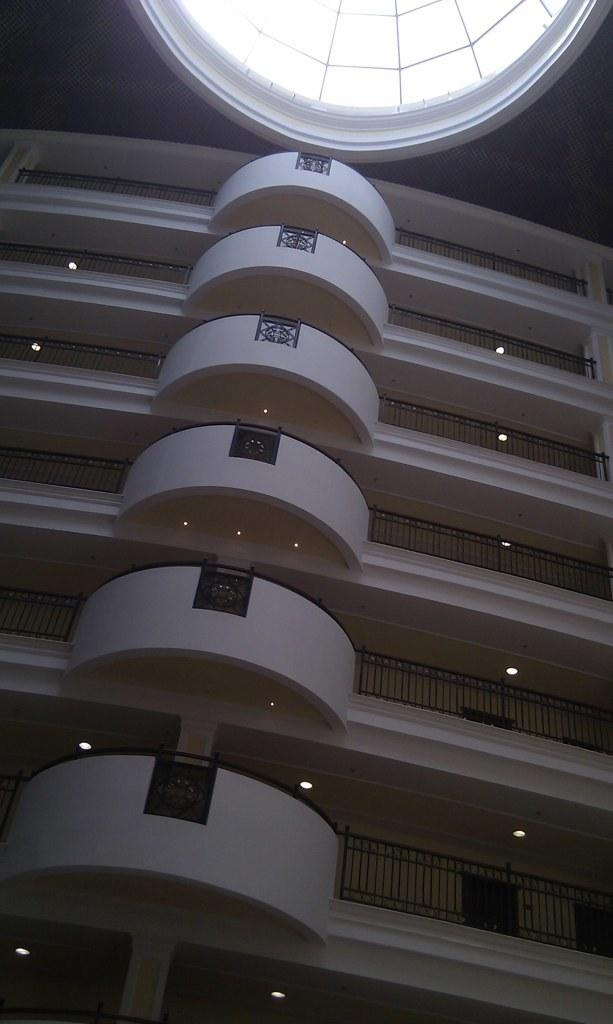What type of structure is present in the image? There is a building in the image. What feature can be seen on the building? The building has railings. Are there any lighting elements on the building? Yes, the building has lights. What material is used for the roof of the building? The roof of the building has glass. Is there a pan hanging from the bridge in the image? There is no bridge present in the image, and therefore no pan hanging from it. 